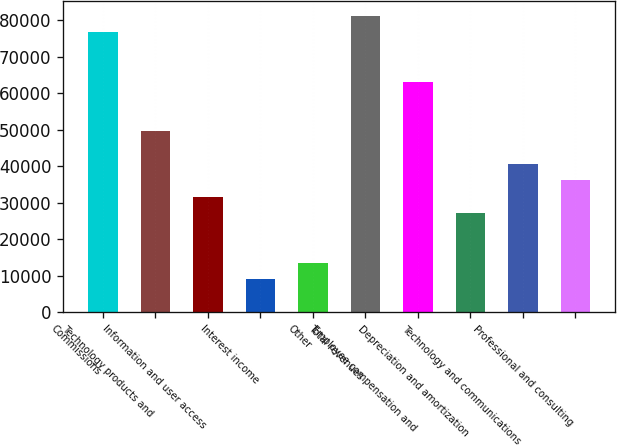<chart> <loc_0><loc_0><loc_500><loc_500><bar_chart><fcel>Commissions<fcel>Technology products and<fcel>Information and user access<fcel>Interest income<fcel>Other<fcel>Total revenues<fcel>Employee compensation and<fcel>Depreciation and amortization<fcel>Technology and communications<fcel>Professional and consulting<nl><fcel>76729.3<fcel>49648.5<fcel>31594.6<fcel>9027.23<fcel>13540.7<fcel>81242.8<fcel>63188.9<fcel>27081.1<fcel>40621.5<fcel>36108.1<nl></chart> 